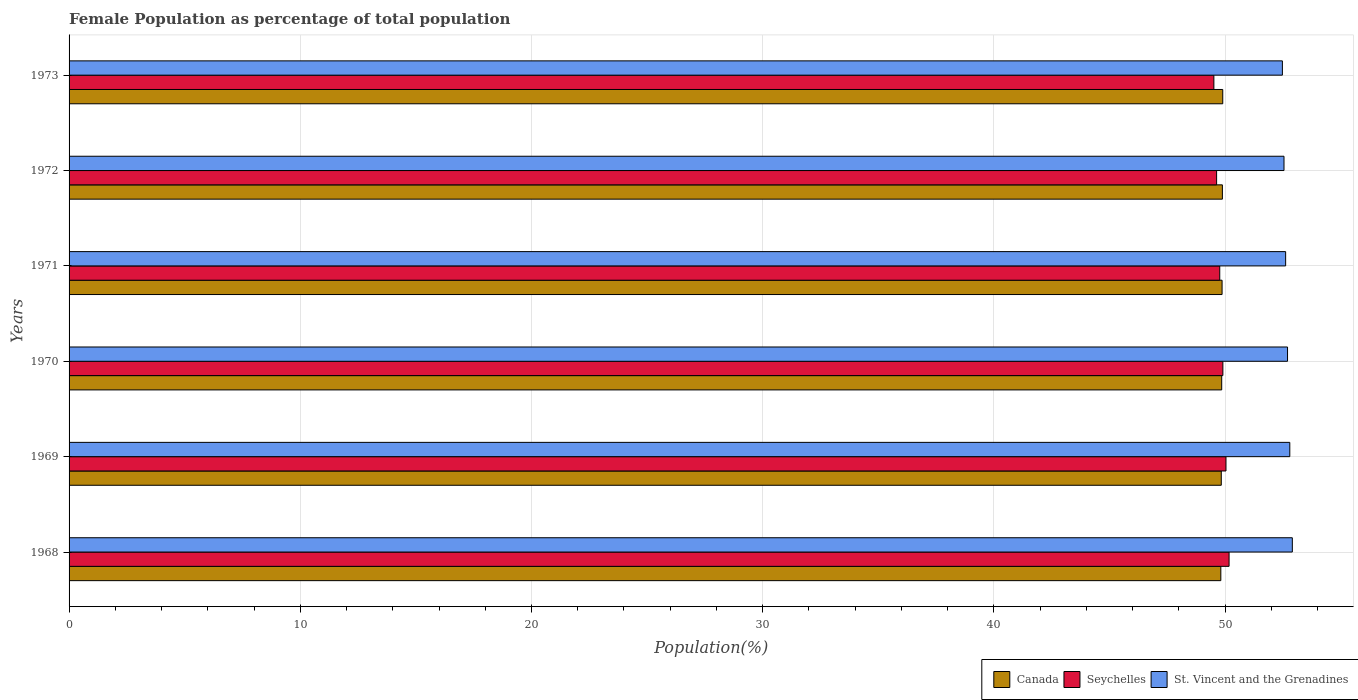Are the number of bars on each tick of the Y-axis equal?
Keep it short and to the point. Yes. How many bars are there on the 4th tick from the top?
Make the answer very short. 3. How many bars are there on the 3rd tick from the bottom?
Make the answer very short. 3. What is the female population in in Seychelles in 1972?
Keep it short and to the point. 49.63. Across all years, what is the maximum female population in in St. Vincent and the Grenadines?
Provide a succinct answer. 52.91. Across all years, what is the minimum female population in in Canada?
Offer a terse response. 49.82. In which year was the female population in in Seychelles maximum?
Your answer should be very brief. 1968. In which year was the female population in in Seychelles minimum?
Provide a short and direct response. 1973. What is the total female population in in St. Vincent and the Grenadines in the graph?
Keep it short and to the point. 316.06. What is the difference between the female population in in Canada in 1968 and that in 1971?
Provide a short and direct response. -0.05. What is the difference between the female population in in Seychelles in 1973 and the female population in in St. Vincent and the Grenadines in 1972?
Ensure brevity in your answer.  -3.03. What is the average female population in in Seychelles per year?
Provide a short and direct response. 49.84. In the year 1969, what is the difference between the female population in in Seychelles and female population in in Canada?
Your answer should be compact. 0.2. In how many years, is the female population in in St. Vincent and the Grenadines greater than 38 %?
Your response must be concise. 6. What is the ratio of the female population in in St. Vincent and the Grenadines in 1970 to that in 1973?
Provide a succinct answer. 1. What is the difference between the highest and the second highest female population in in St. Vincent and the Grenadines?
Give a very brief answer. 0.11. What is the difference between the highest and the lowest female population in in Canada?
Offer a very short reply. 0.08. In how many years, is the female population in in Canada greater than the average female population in in Canada taken over all years?
Ensure brevity in your answer.  3. What does the 1st bar from the top in 1968 represents?
Offer a terse response. St. Vincent and the Grenadines. Is it the case that in every year, the sum of the female population in in Canada and female population in in Seychelles is greater than the female population in in St. Vincent and the Grenadines?
Provide a succinct answer. Yes. How many bars are there?
Your answer should be very brief. 18. What is the difference between two consecutive major ticks on the X-axis?
Keep it short and to the point. 10. Are the values on the major ticks of X-axis written in scientific E-notation?
Ensure brevity in your answer.  No. Does the graph contain any zero values?
Ensure brevity in your answer.  No. Does the graph contain grids?
Offer a very short reply. Yes. Where does the legend appear in the graph?
Your answer should be very brief. Bottom right. How many legend labels are there?
Offer a terse response. 3. How are the legend labels stacked?
Give a very brief answer. Horizontal. What is the title of the graph?
Provide a short and direct response. Female Population as percentage of total population. Does "Low & middle income" appear as one of the legend labels in the graph?
Make the answer very short. No. What is the label or title of the X-axis?
Your answer should be compact. Population(%). What is the label or title of the Y-axis?
Your answer should be very brief. Years. What is the Population(%) in Canada in 1968?
Keep it short and to the point. 49.82. What is the Population(%) of Seychelles in 1968?
Ensure brevity in your answer.  50.17. What is the Population(%) of St. Vincent and the Grenadines in 1968?
Your answer should be compact. 52.91. What is the Population(%) in Canada in 1969?
Ensure brevity in your answer.  49.84. What is the Population(%) in Seychelles in 1969?
Keep it short and to the point. 50.04. What is the Population(%) of St. Vincent and the Grenadines in 1969?
Provide a short and direct response. 52.8. What is the Population(%) in Canada in 1970?
Provide a succinct answer. 49.85. What is the Population(%) of Seychelles in 1970?
Provide a short and direct response. 49.9. What is the Population(%) of St. Vincent and the Grenadines in 1970?
Offer a very short reply. 52.7. What is the Population(%) of Canada in 1971?
Provide a succinct answer. 49.87. What is the Population(%) in Seychelles in 1971?
Offer a very short reply. 49.77. What is the Population(%) of St. Vincent and the Grenadines in 1971?
Provide a succinct answer. 52.62. What is the Population(%) of Canada in 1972?
Make the answer very short. 49.88. What is the Population(%) in Seychelles in 1972?
Your answer should be very brief. 49.63. What is the Population(%) in St. Vincent and the Grenadines in 1972?
Keep it short and to the point. 52.55. What is the Population(%) in Canada in 1973?
Your response must be concise. 49.9. What is the Population(%) of Seychelles in 1973?
Provide a succinct answer. 49.52. What is the Population(%) in St. Vincent and the Grenadines in 1973?
Make the answer very short. 52.48. Across all years, what is the maximum Population(%) of Canada?
Keep it short and to the point. 49.9. Across all years, what is the maximum Population(%) of Seychelles?
Provide a short and direct response. 50.17. Across all years, what is the maximum Population(%) in St. Vincent and the Grenadines?
Offer a very short reply. 52.91. Across all years, what is the minimum Population(%) of Canada?
Provide a succinct answer. 49.82. Across all years, what is the minimum Population(%) in Seychelles?
Your answer should be very brief. 49.52. Across all years, what is the minimum Population(%) in St. Vincent and the Grenadines?
Offer a very short reply. 52.48. What is the total Population(%) of Canada in the graph?
Your response must be concise. 299.16. What is the total Population(%) in Seychelles in the graph?
Offer a terse response. 299.03. What is the total Population(%) of St. Vincent and the Grenadines in the graph?
Your answer should be very brief. 316.06. What is the difference between the Population(%) in Canada in 1968 and that in 1969?
Offer a terse response. -0.02. What is the difference between the Population(%) of Seychelles in 1968 and that in 1969?
Provide a short and direct response. 0.13. What is the difference between the Population(%) in St. Vincent and the Grenadines in 1968 and that in 1969?
Your response must be concise. 0.11. What is the difference between the Population(%) in Canada in 1968 and that in 1970?
Your response must be concise. -0.04. What is the difference between the Population(%) of Seychelles in 1968 and that in 1970?
Your answer should be compact. 0.27. What is the difference between the Population(%) of St. Vincent and the Grenadines in 1968 and that in 1970?
Keep it short and to the point. 0.21. What is the difference between the Population(%) in Canada in 1968 and that in 1971?
Your answer should be very brief. -0.05. What is the difference between the Population(%) in Seychelles in 1968 and that in 1971?
Ensure brevity in your answer.  0.4. What is the difference between the Population(%) of St. Vincent and the Grenadines in 1968 and that in 1971?
Offer a terse response. 0.29. What is the difference between the Population(%) in Canada in 1968 and that in 1972?
Your answer should be very brief. -0.07. What is the difference between the Population(%) of Seychelles in 1968 and that in 1972?
Make the answer very short. 0.54. What is the difference between the Population(%) of St. Vincent and the Grenadines in 1968 and that in 1972?
Keep it short and to the point. 0.36. What is the difference between the Population(%) in Canada in 1968 and that in 1973?
Provide a short and direct response. -0.08. What is the difference between the Population(%) of Seychelles in 1968 and that in 1973?
Ensure brevity in your answer.  0.66. What is the difference between the Population(%) in St. Vincent and the Grenadines in 1968 and that in 1973?
Offer a terse response. 0.43. What is the difference between the Population(%) in Canada in 1969 and that in 1970?
Ensure brevity in your answer.  -0.02. What is the difference between the Population(%) of Seychelles in 1969 and that in 1970?
Offer a terse response. 0.13. What is the difference between the Population(%) of St. Vincent and the Grenadines in 1969 and that in 1970?
Offer a terse response. 0.1. What is the difference between the Population(%) of Canada in 1969 and that in 1971?
Ensure brevity in your answer.  -0.03. What is the difference between the Population(%) of Seychelles in 1969 and that in 1971?
Offer a very short reply. 0.27. What is the difference between the Population(%) in St. Vincent and the Grenadines in 1969 and that in 1971?
Provide a succinct answer. 0.18. What is the difference between the Population(%) of Canada in 1969 and that in 1972?
Your response must be concise. -0.05. What is the difference between the Population(%) in Seychelles in 1969 and that in 1972?
Offer a terse response. 0.41. What is the difference between the Population(%) in St. Vincent and the Grenadines in 1969 and that in 1972?
Offer a terse response. 0.25. What is the difference between the Population(%) of Canada in 1969 and that in 1973?
Offer a very short reply. -0.06. What is the difference between the Population(%) of Seychelles in 1969 and that in 1973?
Your answer should be very brief. 0.52. What is the difference between the Population(%) of St. Vincent and the Grenadines in 1969 and that in 1973?
Keep it short and to the point. 0.32. What is the difference between the Population(%) in Canada in 1970 and that in 1971?
Provide a succinct answer. -0.02. What is the difference between the Population(%) of Seychelles in 1970 and that in 1971?
Offer a terse response. 0.14. What is the difference between the Population(%) of St. Vincent and the Grenadines in 1970 and that in 1971?
Provide a succinct answer. 0.08. What is the difference between the Population(%) in Canada in 1970 and that in 1972?
Give a very brief answer. -0.03. What is the difference between the Population(%) of Seychelles in 1970 and that in 1972?
Provide a succinct answer. 0.27. What is the difference between the Population(%) in St. Vincent and the Grenadines in 1970 and that in 1972?
Offer a very short reply. 0.15. What is the difference between the Population(%) in Canada in 1970 and that in 1973?
Make the answer very short. -0.04. What is the difference between the Population(%) of Seychelles in 1970 and that in 1973?
Your answer should be very brief. 0.39. What is the difference between the Population(%) in St. Vincent and the Grenadines in 1970 and that in 1973?
Offer a terse response. 0.22. What is the difference between the Population(%) of Canada in 1971 and that in 1972?
Make the answer very short. -0.01. What is the difference between the Population(%) of Seychelles in 1971 and that in 1972?
Make the answer very short. 0.14. What is the difference between the Population(%) of St. Vincent and the Grenadines in 1971 and that in 1972?
Provide a succinct answer. 0.07. What is the difference between the Population(%) of Canada in 1971 and that in 1973?
Provide a succinct answer. -0.03. What is the difference between the Population(%) in Seychelles in 1971 and that in 1973?
Provide a short and direct response. 0.25. What is the difference between the Population(%) of St. Vincent and the Grenadines in 1971 and that in 1973?
Your answer should be very brief. 0.14. What is the difference between the Population(%) in Canada in 1972 and that in 1973?
Offer a very short reply. -0.02. What is the difference between the Population(%) in Seychelles in 1972 and that in 1973?
Provide a succinct answer. 0.12. What is the difference between the Population(%) of St. Vincent and the Grenadines in 1972 and that in 1973?
Make the answer very short. 0.07. What is the difference between the Population(%) in Canada in 1968 and the Population(%) in Seychelles in 1969?
Your answer should be compact. -0.22. What is the difference between the Population(%) in Canada in 1968 and the Population(%) in St. Vincent and the Grenadines in 1969?
Keep it short and to the point. -2.98. What is the difference between the Population(%) of Seychelles in 1968 and the Population(%) of St. Vincent and the Grenadines in 1969?
Provide a succinct answer. -2.63. What is the difference between the Population(%) in Canada in 1968 and the Population(%) in Seychelles in 1970?
Your response must be concise. -0.09. What is the difference between the Population(%) in Canada in 1968 and the Population(%) in St. Vincent and the Grenadines in 1970?
Give a very brief answer. -2.89. What is the difference between the Population(%) in Seychelles in 1968 and the Population(%) in St. Vincent and the Grenadines in 1970?
Your response must be concise. -2.53. What is the difference between the Population(%) in Canada in 1968 and the Population(%) in Seychelles in 1971?
Offer a terse response. 0.05. What is the difference between the Population(%) of Canada in 1968 and the Population(%) of St. Vincent and the Grenadines in 1971?
Your answer should be very brief. -2.8. What is the difference between the Population(%) in Seychelles in 1968 and the Population(%) in St. Vincent and the Grenadines in 1971?
Make the answer very short. -2.45. What is the difference between the Population(%) of Canada in 1968 and the Population(%) of Seychelles in 1972?
Offer a terse response. 0.18. What is the difference between the Population(%) of Canada in 1968 and the Population(%) of St. Vincent and the Grenadines in 1972?
Provide a succinct answer. -2.73. What is the difference between the Population(%) of Seychelles in 1968 and the Population(%) of St. Vincent and the Grenadines in 1972?
Keep it short and to the point. -2.38. What is the difference between the Population(%) in Canada in 1968 and the Population(%) in Seychelles in 1973?
Your answer should be very brief. 0.3. What is the difference between the Population(%) of Canada in 1968 and the Population(%) of St. Vincent and the Grenadines in 1973?
Provide a succinct answer. -2.66. What is the difference between the Population(%) of Seychelles in 1968 and the Population(%) of St. Vincent and the Grenadines in 1973?
Ensure brevity in your answer.  -2.31. What is the difference between the Population(%) in Canada in 1969 and the Population(%) in Seychelles in 1970?
Ensure brevity in your answer.  -0.07. What is the difference between the Population(%) in Canada in 1969 and the Population(%) in St. Vincent and the Grenadines in 1970?
Ensure brevity in your answer.  -2.87. What is the difference between the Population(%) in Seychelles in 1969 and the Population(%) in St. Vincent and the Grenadines in 1970?
Your answer should be very brief. -2.66. What is the difference between the Population(%) in Canada in 1969 and the Population(%) in Seychelles in 1971?
Offer a very short reply. 0.07. What is the difference between the Population(%) in Canada in 1969 and the Population(%) in St. Vincent and the Grenadines in 1971?
Provide a short and direct response. -2.78. What is the difference between the Population(%) in Seychelles in 1969 and the Population(%) in St. Vincent and the Grenadines in 1971?
Offer a very short reply. -2.58. What is the difference between the Population(%) of Canada in 1969 and the Population(%) of Seychelles in 1972?
Your answer should be very brief. 0.2. What is the difference between the Population(%) of Canada in 1969 and the Population(%) of St. Vincent and the Grenadines in 1972?
Your answer should be compact. -2.71. What is the difference between the Population(%) of Seychelles in 1969 and the Population(%) of St. Vincent and the Grenadines in 1972?
Provide a short and direct response. -2.51. What is the difference between the Population(%) in Canada in 1969 and the Population(%) in Seychelles in 1973?
Your answer should be very brief. 0.32. What is the difference between the Population(%) in Canada in 1969 and the Population(%) in St. Vincent and the Grenadines in 1973?
Provide a short and direct response. -2.64. What is the difference between the Population(%) of Seychelles in 1969 and the Population(%) of St. Vincent and the Grenadines in 1973?
Make the answer very short. -2.44. What is the difference between the Population(%) in Canada in 1970 and the Population(%) in Seychelles in 1971?
Provide a succinct answer. 0.08. What is the difference between the Population(%) of Canada in 1970 and the Population(%) of St. Vincent and the Grenadines in 1971?
Provide a succinct answer. -2.77. What is the difference between the Population(%) in Seychelles in 1970 and the Population(%) in St. Vincent and the Grenadines in 1971?
Your answer should be compact. -2.71. What is the difference between the Population(%) in Canada in 1970 and the Population(%) in Seychelles in 1972?
Your answer should be compact. 0.22. What is the difference between the Population(%) in Canada in 1970 and the Population(%) in St. Vincent and the Grenadines in 1972?
Keep it short and to the point. -2.69. What is the difference between the Population(%) in Seychelles in 1970 and the Population(%) in St. Vincent and the Grenadines in 1972?
Your answer should be very brief. -2.64. What is the difference between the Population(%) in Canada in 1970 and the Population(%) in Seychelles in 1973?
Your response must be concise. 0.34. What is the difference between the Population(%) in Canada in 1970 and the Population(%) in St. Vincent and the Grenadines in 1973?
Keep it short and to the point. -2.62. What is the difference between the Population(%) of Seychelles in 1970 and the Population(%) of St. Vincent and the Grenadines in 1973?
Make the answer very short. -2.57. What is the difference between the Population(%) of Canada in 1971 and the Population(%) of Seychelles in 1972?
Your answer should be compact. 0.24. What is the difference between the Population(%) of Canada in 1971 and the Population(%) of St. Vincent and the Grenadines in 1972?
Keep it short and to the point. -2.68. What is the difference between the Population(%) of Seychelles in 1971 and the Population(%) of St. Vincent and the Grenadines in 1972?
Your response must be concise. -2.78. What is the difference between the Population(%) in Canada in 1971 and the Population(%) in Seychelles in 1973?
Keep it short and to the point. 0.35. What is the difference between the Population(%) of Canada in 1971 and the Population(%) of St. Vincent and the Grenadines in 1973?
Make the answer very short. -2.61. What is the difference between the Population(%) of Seychelles in 1971 and the Population(%) of St. Vincent and the Grenadines in 1973?
Keep it short and to the point. -2.71. What is the difference between the Population(%) of Canada in 1972 and the Population(%) of Seychelles in 1973?
Keep it short and to the point. 0.37. What is the difference between the Population(%) of Canada in 1972 and the Population(%) of St. Vincent and the Grenadines in 1973?
Provide a succinct answer. -2.6. What is the difference between the Population(%) of Seychelles in 1972 and the Population(%) of St. Vincent and the Grenadines in 1973?
Give a very brief answer. -2.85. What is the average Population(%) of Canada per year?
Your answer should be very brief. 49.86. What is the average Population(%) in Seychelles per year?
Offer a terse response. 49.84. What is the average Population(%) in St. Vincent and the Grenadines per year?
Offer a very short reply. 52.68. In the year 1968, what is the difference between the Population(%) in Canada and Population(%) in Seychelles?
Offer a very short reply. -0.36. In the year 1968, what is the difference between the Population(%) in Canada and Population(%) in St. Vincent and the Grenadines?
Your answer should be very brief. -3.09. In the year 1968, what is the difference between the Population(%) of Seychelles and Population(%) of St. Vincent and the Grenadines?
Your response must be concise. -2.74. In the year 1969, what is the difference between the Population(%) of Canada and Population(%) of Seychelles?
Keep it short and to the point. -0.2. In the year 1969, what is the difference between the Population(%) in Canada and Population(%) in St. Vincent and the Grenadines?
Your answer should be very brief. -2.96. In the year 1969, what is the difference between the Population(%) of Seychelles and Population(%) of St. Vincent and the Grenadines?
Offer a very short reply. -2.76. In the year 1970, what is the difference between the Population(%) in Canada and Population(%) in Seychelles?
Offer a terse response. -0.05. In the year 1970, what is the difference between the Population(%) in Canada and Population(%) in St. Vincent and the Grenadines?
Provide a succinct answer. -2.85. In the year 1970, what is the difference between the Population(%) in Seychelles and Population(%) in St. Vincent and the Grenadines?
Your answer should be compact. -2.8. In the year 1971, what is the difference between the Population(%) of Canada and Population(%) of Seychelles?
Your answer should be compact. 0.1. In the year 1971, what is the difference between the Population(%) of Canada and Population(%) of St. Vincent and the Grenadines?
Your response must be concise. -2.75. In the year 1971, what is the difference between the Population(%) in Seychelles and Population(%) in St. Vincent and the Grenadines?
Make the answer very short. -2.85. In the year 1972, what is the difference between the Population(%) of Canada and Population(%) of Seychelles?
Keep it short and to the point. 0.25. In the year 1972, what is the difference between the Population(%) in Canada and Population(%) in St. Vincent and the Grenadines?
Ensure brevity in your answer.  -2.66. In the year 1972, what is the difference between the Population(%) in Seychelles and Population(%) in St. Vincent and the Grenadines?
Ensure brevity in your answer.  -2.92. In the year 1973, what is the difference between the Population(%) of Canada and Population(%) of Seychelles?
Your response must be concise. 0.38. In the year 1973, what is the difference between the Population(%) of Canada and Population(%) of St. Vincent and the Grenadines?
Make the answer very short. -2.58. In the year 1973, what is the difference between the Population(%) of Seychelles and Population(%) of St. Vincent and the Grenadines?
Provide a short and direct response. -2.96. What is the ratio of the Population(%) in Canada in 1968 to that in 1969?
Make the answer very short. 1. What is the ratio of the Population(%) of Seychelles in 1968 to that in 1969?
Provide a short and direct response. 1. What is the ratio of the Population(%) in Seychelles in 1968 to that in 1970?
Make the answer very short. 1.01. What is the ratio of the Population(%) of Canada in 1968 to that in 1971?
Make the answer very short. 1. What is the ratio of the Population(%) in Seychelles in 1968 to that in 1971?
Keep it short and to the point. 1.01. What is the ratio of the Population(%) of St. Vincent and the Grenadines in 1968 to that in 1971?
Provide a short and direct response. 1.01. What is the ratio of the Population(%) of Canada in 1968 to that in 1972?
Your answer should be very brief. 1. What is the ratio of the Population(%) in Seychelles in 1968 to that in 1972?
Your answer should be very brief. 1.01. What is the ratio of the Population(%) of Seychelles in 1968 to that in 1973?
Ensure brevity in your answer.  1.01. What is the ratio of the Population(%) in St. Vincent and the Grenadines in 1968 to that in 1973?
Ensure brevity in your answer.  1.01. What is the ratio of the Population(%) of Canada in 1969 to that in 1970?
Offer a terse response. 1. What is the ratio of the Population(%) in St. Vincent and the Grenadines in 1969 to that in 1970?
Make the answer very short. 1. What is the ratio of the Population(%) in Canada in 1969 to that in 1971?
Provide a short and direct response. 1. What is the ratio of the Population(%) in Seychelles in 1969 to that in 1971?
Your answer should be compact. 1.01. What is the ratio of the Population(%) of Canada in 1969 to that in 1972?
Offer a terse response. 1. What is the ratio of the Population(%) of Seychelles in 1969 to that in 1972?
Offer a terse response. 1.01. What is the ratio of the Population(%) in Seychelles in 1969 to that in 1973?
Keep it short and to the point. 1.01. What is the ratio of the Population(%) in St. Vincent and the Grenadines in 1969 to that in 1973?
Ensure brevity in your answer.  1.01. What is the ratio of the Population(%) of Canada in 1970 to that in 1971?
Your response must be concise. 1. What is the ratio of the Population(%) in St. Vincent and the Grenadines in 1970 to that in 1971?
Provide a short and direct response. 1. What is the ratio of the Population(%) in Canada in 1970 to that in 1972?
Keep it short and to the point. 1. What is the ratio of the Population(%) in St. Vincent and the Grenadines in 1970 to that in 1972?
Give a very brief answer. 1. What is the ratio of the Population(%) in Canada in 1970 to that in 1973?
Keep it short and to the point. 1. What is the ratio of the Population(%) in Seychelles in 1970 to that in 1973?
Offer a very short reply. 1.01. What is the ratio of the Population(%) in Seychelles in 1971 to that in 1972?
Provide a short and direct response. 1. What is the ratio of the Population(%) in Canada in 1971 to that in 1973?
Make the answer very short. 1. What is the ratio of the Population(%) of St. Vincent and the Grenadines in 1971 to that in 1973?
Offer a terse response. 1. What is the ratio of the Population(%) in St. Vincent and the Grenadines in 1972 to that in 1973?
Offer a terse response. 1. What is the difference between the highest and the second highest Population(%) of Canada?
Your answer should be very brief. 0.02. What is the difference between the highest and the second highest Population(%) of Seychelles?
Your response must be concise. 0.13. What is the difference between the highest and the second highest Population(%) in St. Vincent and the Grenadines?
Provide a short and direct response. 0.11. What is the difference between the highest and the lowest Population(%) of Canada?
Your answer should be very brief. 0.08. What is the difference between the highest and the lowest Population(%) in Seychelles?
Offer a terse response. 0.66. What is the difference between the highest and the lowest Population(%) of St. Vincent and the Grenadines?
Offer a terse response. 0.43. 